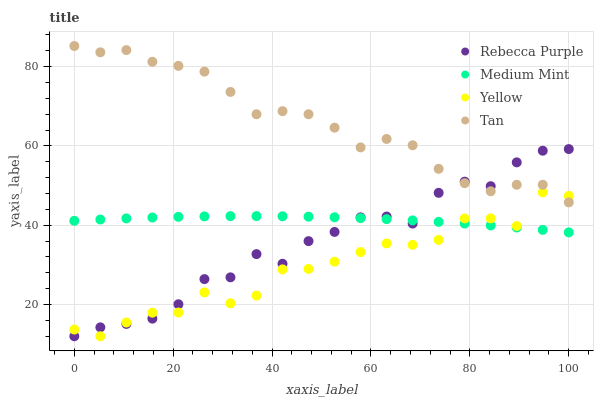Does Yellow have the minimum area under the curve?
Answer yes or no. Yes. Does Tan have the maximum area under the curve?
Answer yes or no. Yes. Does Rebecca Purple have the minimum area under the curve?
Answer yes or no. No. Does Rebecca Purple have the maximum area under the curve?
Answer yes or no. No. Is Medium Mint the smoothest?
Answer yes or no. Yes. Is Rebecca Purple the roughest?
Answer yes or no. Yes. Is Tan the smoothest?
Answer yes or no. No. Is Tan the roughest?
Answer yes or no. No. Does Rebecca Purple have the lowest value?
Answer yes or no. Yes. Does Tan have the lowest value?
Answer yes or no. No. Does Tan have the highest value?
Answer yes or no. Yes. Does Rebecca Purple have the highest value?
Answer yes or no. No. Is Medium Mint less than Tan?
Answer yes or no. Yes. Is Tan greater than Medium Mint?
Answer yes or no. Yes. Does Yellow intersect Tan?
Answer yes or no. Yes. Is Yellow less than Tan?
Answer yes or no. No. Is Yellow greater than Tan?
Answer yes or no. No. Does Medium Mint intersect Tan?
Answer yes or no. No. 